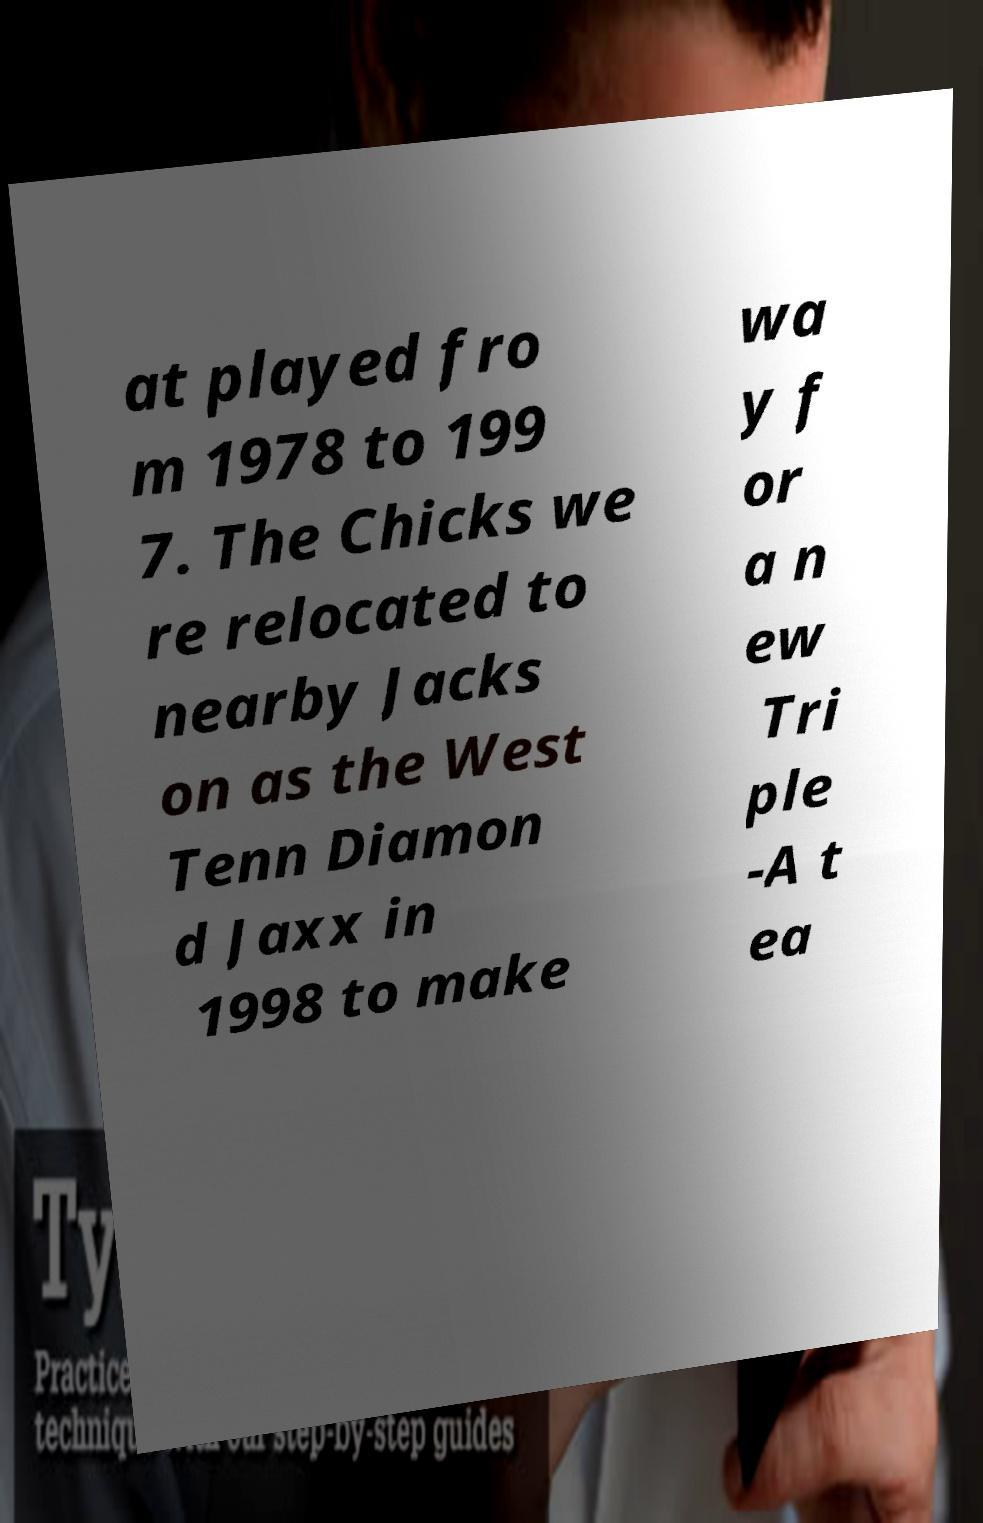Could you extract and type out the text from this image? at played fro m 1978 to 199 7. The Chicks we re relocated to nearby Jacks on as the West Tenn Diamon d Jaxx in 1998 to make wa y f or a n ew Tri ple -A t ea 